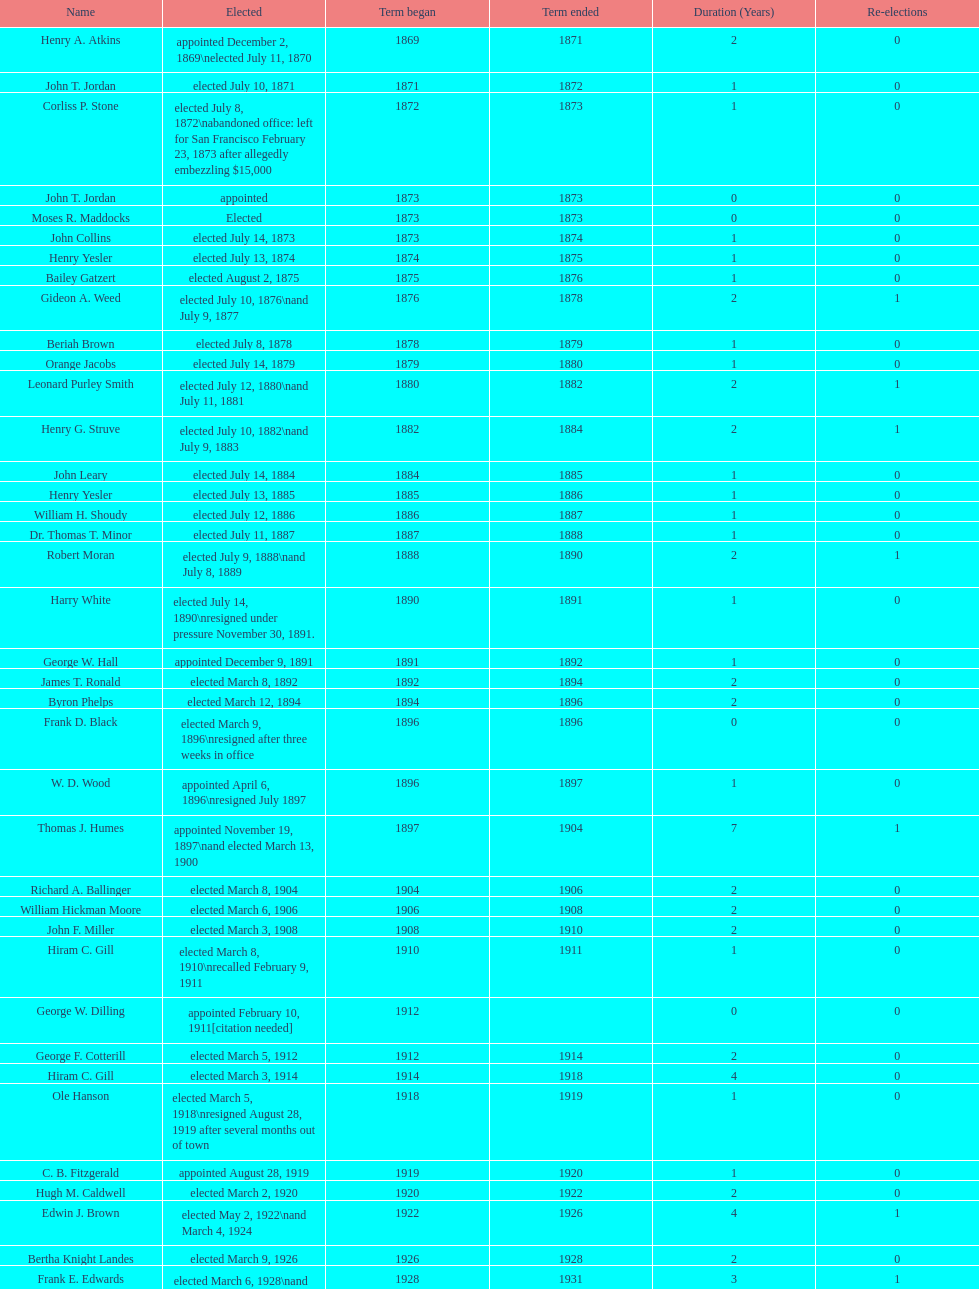Which mayor seattle, washington resigned after only three weeks in office in 1896? Frank D. Black. 